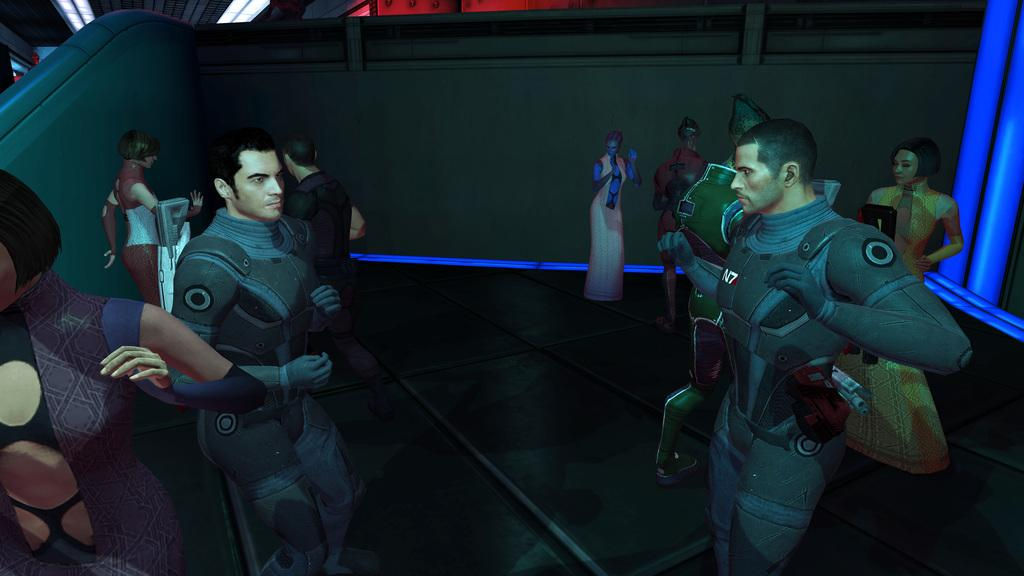What type of object is depicted as a person standing in the image? There are toys of a person standing in the image. What color is the light in the right corner of the image? There is a blue light in the right corner of the image. What can be seen in the background of the image? There are other objects present in the background of the image. Can you tell me how many birds are flying in the image? There are no birds present in the image; it features toys of a person standing and a blue light in the right corner. 